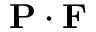<formula> <loc_0><loc_0><loc_500><loc_500>{ P } \cdot { F }</formula> 